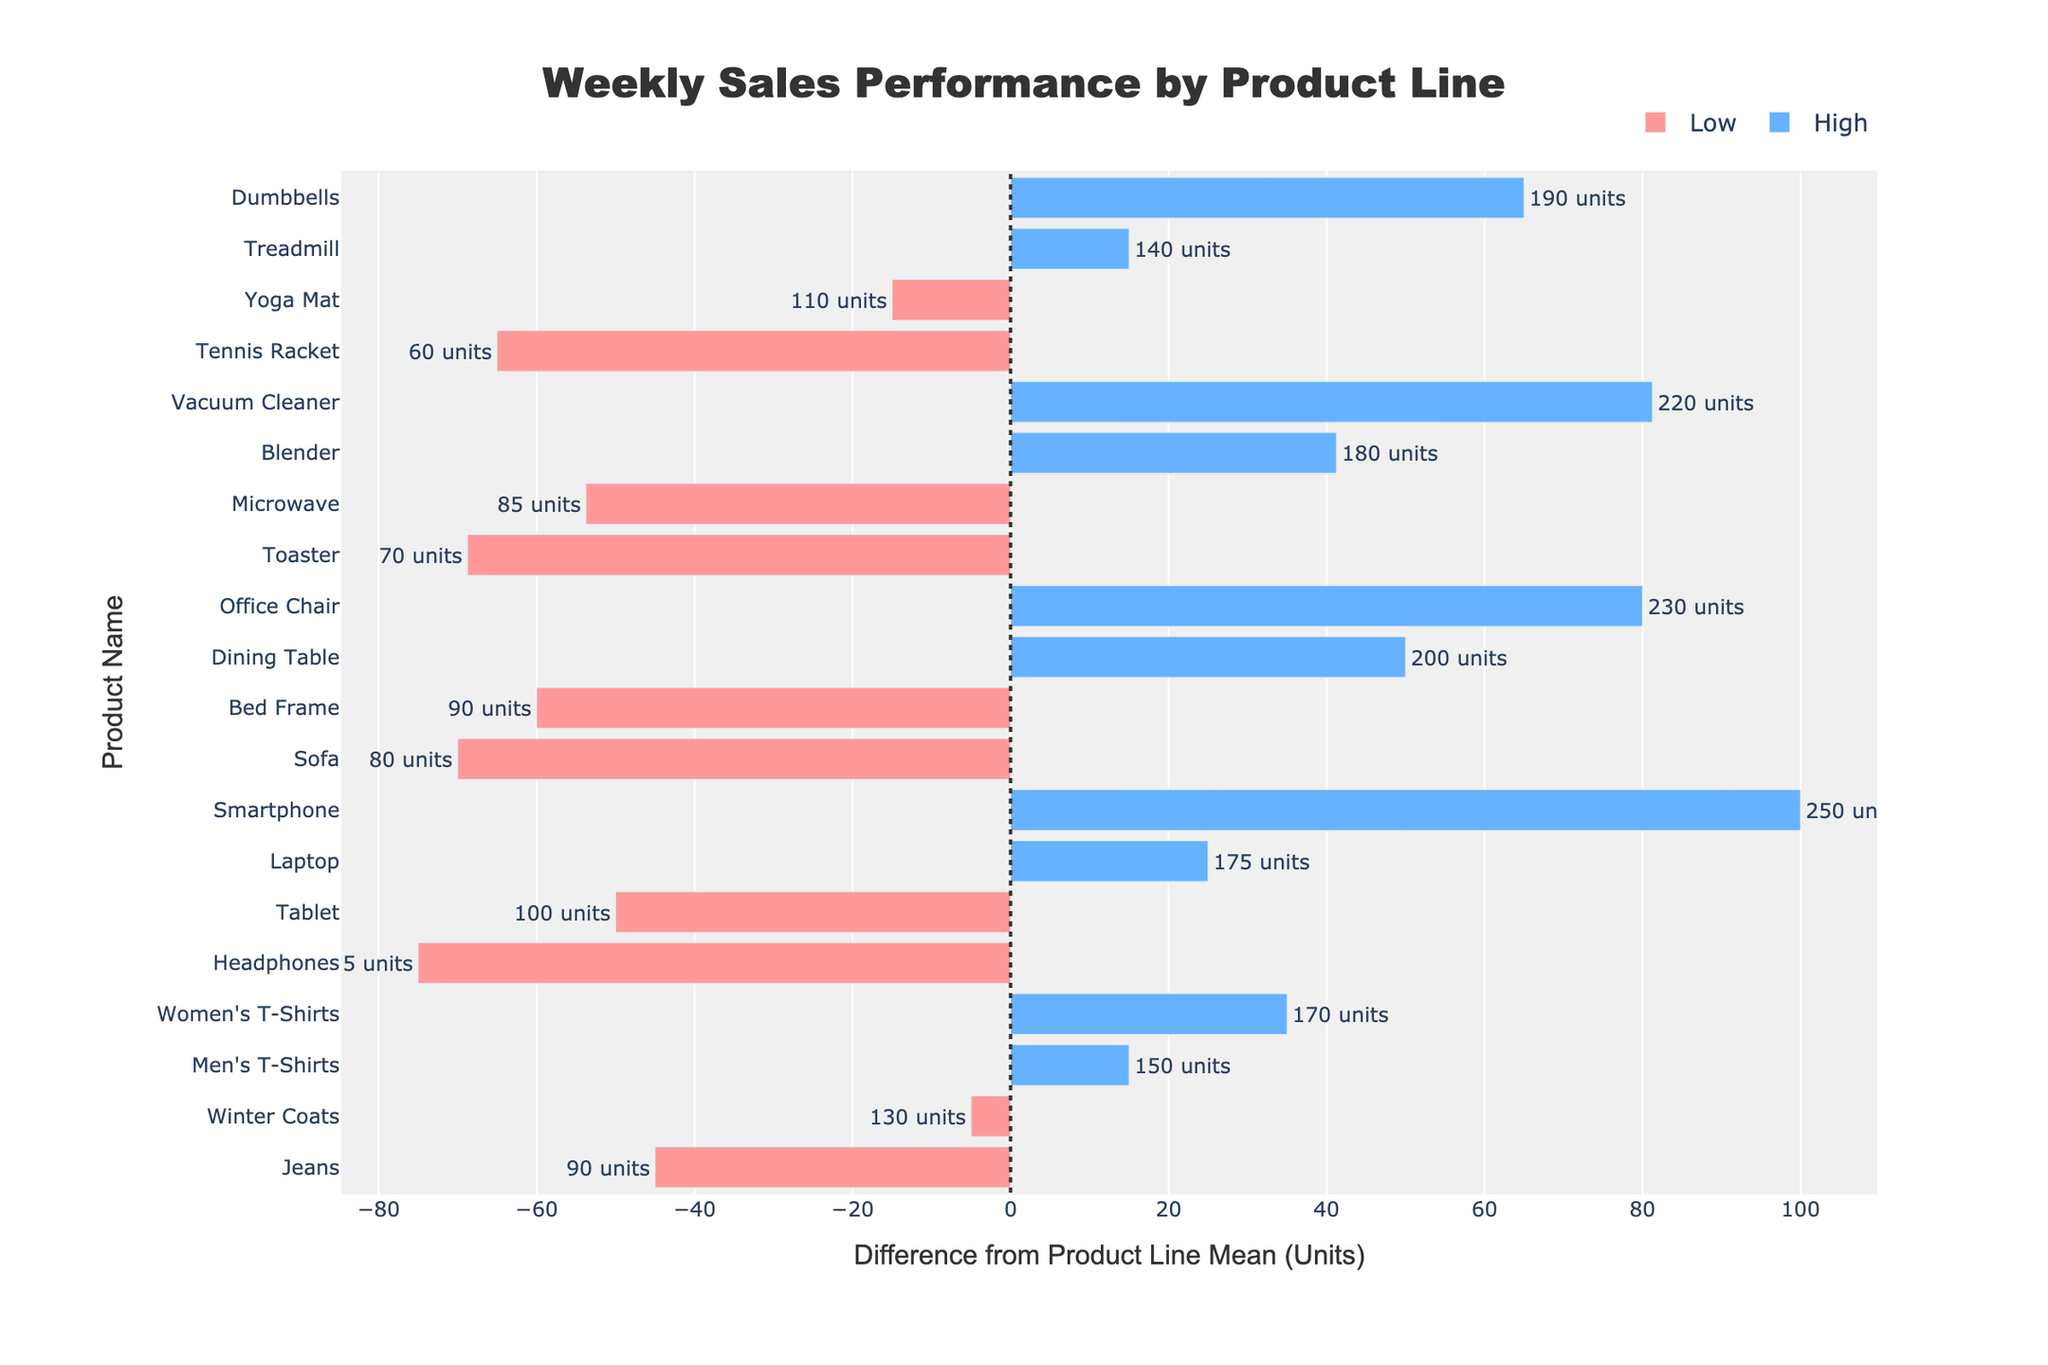What's the difference in sales units between the highest-selling and lowest-selling item in the Electronics category? The highest-selling item in the Electronics category is the Smartphone with 250 units, and the lowest-selling is Headphones with 75 units. Thus, the difference is 250 - 75.
Answer: 175 Which product line has the highest mean sales units on average? From the chart, the mean sales units for each product line can be deduced and compared. The product line with the highest mean sales units is Home Appliances.
Answer: Home Appliances How many products in the Clothing line are classified as high selling? By counting the number of bars in the Clothing line that are colored blue (indicating high selling), there are two high selling products: Men’s T-Shirts and Women’s T-Shirts.
Answer: 2 Which product in the Furniture line has the highest positive difference from the mean? Examine the Furniture line and find the product with the highest positive difference from the mean. The Dining Table has the highest positive difference from the mean.
Answer: Dining Table Which item in the Sports Equipment category has the lowest sales units? Looking at the Sports Equipment category, the Tennis Racket has the lowest sales units with 60 units.
Answer: Tennis Racket Are there more low-selling items or high-selling items in the Home Appliances category? By counting the red and blue bars in the Home Appliances category, there are two low-selling items (Microwave and Toaster) and two high-selling items (Vacuum Cleaner and Blender), thus they are equal.
Answer: Equal What is the sum of sales units for high-selling items in the Clothing category? Summing the units for high-selling items in Clothing, Men’s T-Shirts (150) and Women’s T-Shirts (170), the total is 150 + 170.
Answer: 320 Which product category has the most items with sales units below the mean? Count the number of products in each category that fall below the mean, as indicated by the negative differences. Electronics, with three low-selling items (Tablet, Headphones, and Bed Frame), has the most items below the mean.
Answer: Electronics 